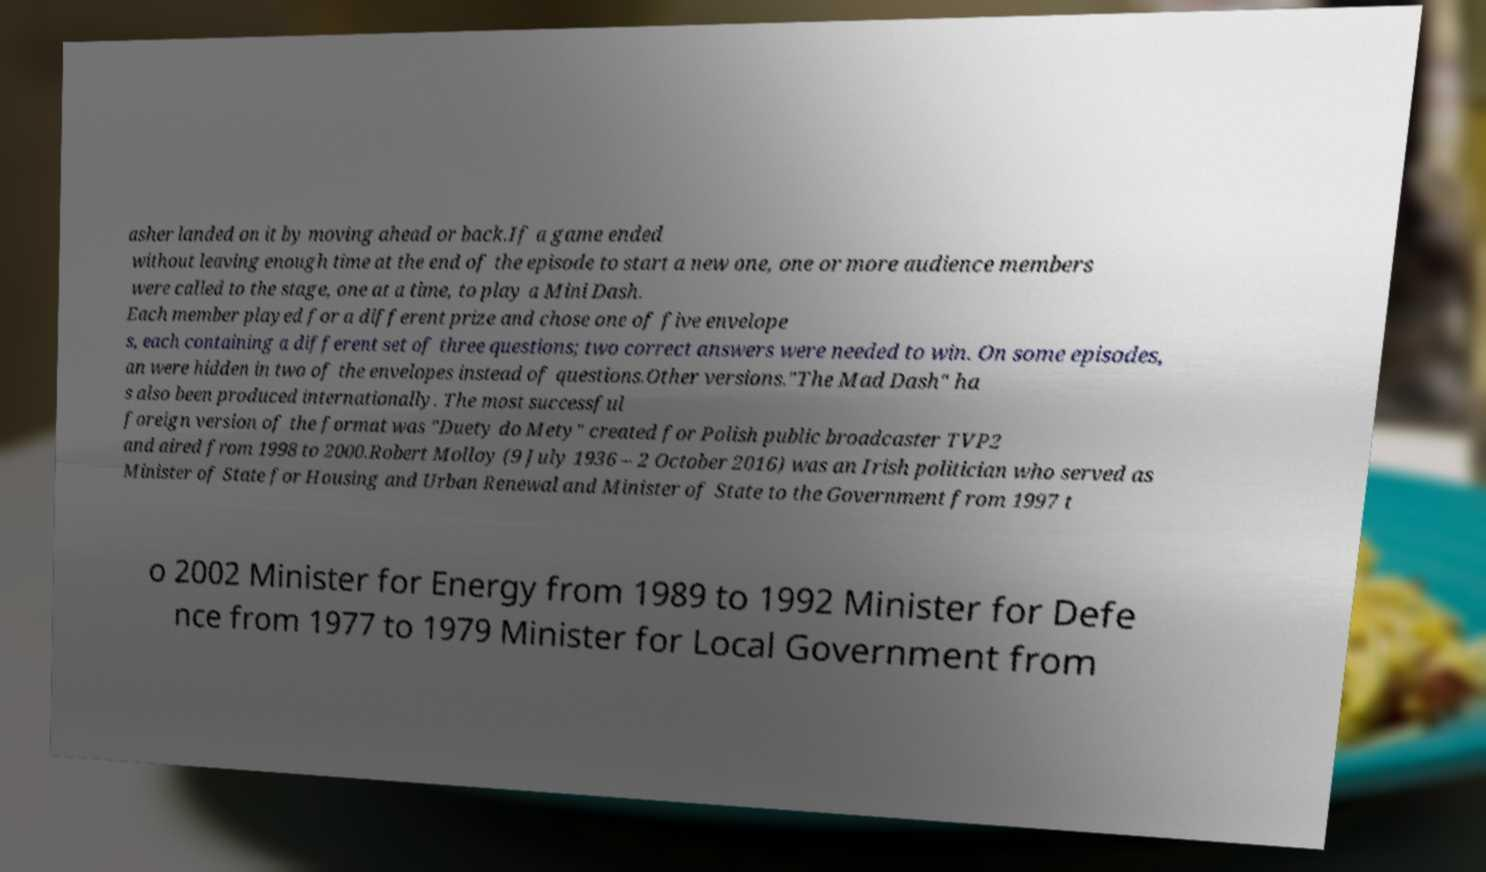Can you read and provide the text displayed in the image?This photo seems to have some interesting text. Can you extract and type it out for me? asher landed on it by moving ahead or back.If a game ended without leaving enough time at the end of the episode to start a new one, one or more audience members were called to the stage, one at a time, to play a Mini Dash. Each member played for a different prize and chose one of five envelope s, each containing a different set of three questions; two correct answers were needed to win. On some episodes, an were hidden in two of the envelopes instead of questions.Other versions."The Mad Dash" ha s also been produced internationally. The most successful foreign version of the format was "Duety do Mety" created for Polish public broadcaster TVP2 and aired from 1998 to 2000.Robert Molloy (9 July 1936 – 2 October 2016) was an Irish politician who served as Minister of State for Housing and Urban Renewal and Minister of State to the Government from 1997 t o 2002 Minister for Energy from 1989 to 1992 Minister for Defe nce from 1977 to 1979 Minister for Local Government from 